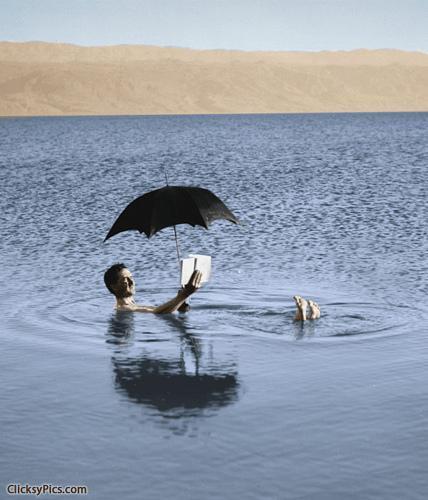How many men?
Give a very brief answer. 1. 